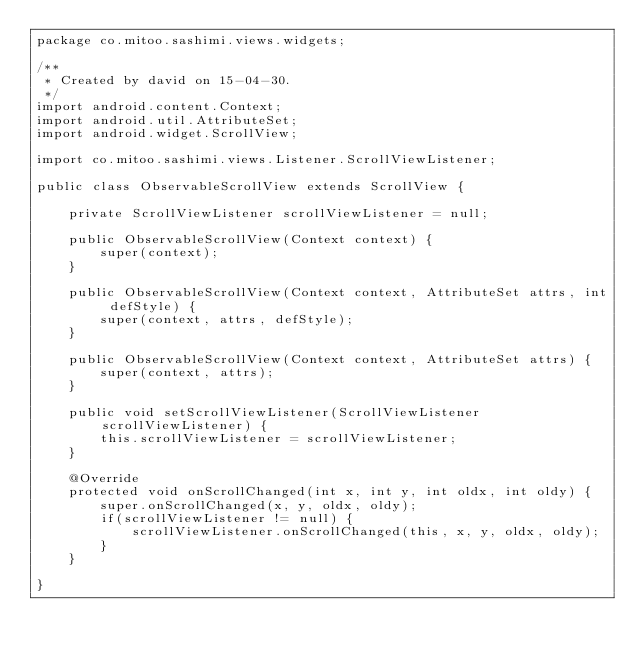<code> <loc_0><loc_0><loc_500><loc_500><_Java_>package co.mitoo.sashimi.views.widgets;

/**
 * Created by david on 15-04-30.
 */
import android.content.Context;
import android.util.AttributeSet;
import android.widget.ScrollView;

import co.mitoo.sashimi.views.Listener.ScrollViewListener;

public class ObservableScrollView extends ScrollView {

    private ScrollViewListener scrollViewListener = null;

    public ObservableScrollView(Context context) {
        super(context);
    }

    public ObservableScrollView(Context context, AttributeSet attrs, int defStyle) {
        super(context, attrs, defStyle);
    }

    public ObservableScrollView(Context context, AttributeSet attrs) {
        super(context, attrs);
    }

    public void setScrollViewListener(ScrollViewListener scrollViewListener) {
        this.scrollViewListener = scrollViewListener;
    }

    @Override
    protected void onScrollChanged(int x, int y, int oldx, int oldy) {
        super.onScrollChanged(x, y, oldx, oldy);
        if(scrollViewListener != null) {
            scrollViewListener.onScrollChanged(this, x, y, oldx, oldy);
        }
    }

}</code> 